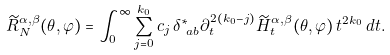<formula> <loc_0><loc_0><loc_500><loc_500>\widetilde { R } _ { N } ^ { \alpha , \beta } ( \theta , \varphi ) & = \int _ { 0 } ^ { \infty } \sum _ { j = 0 } ^ { k _ { 0 } } c _ { j } \, \delta ^ { * } _ { \ a b } \partial _ { t } ^ { 2 ( k _ { 0 } - j ) } \widetilde { H } _ { t } ^ { \alpha , \beta } ( \theta , \varphi ) \, t ^ { 2 k _ { 0 } } \, d t .</formula> 